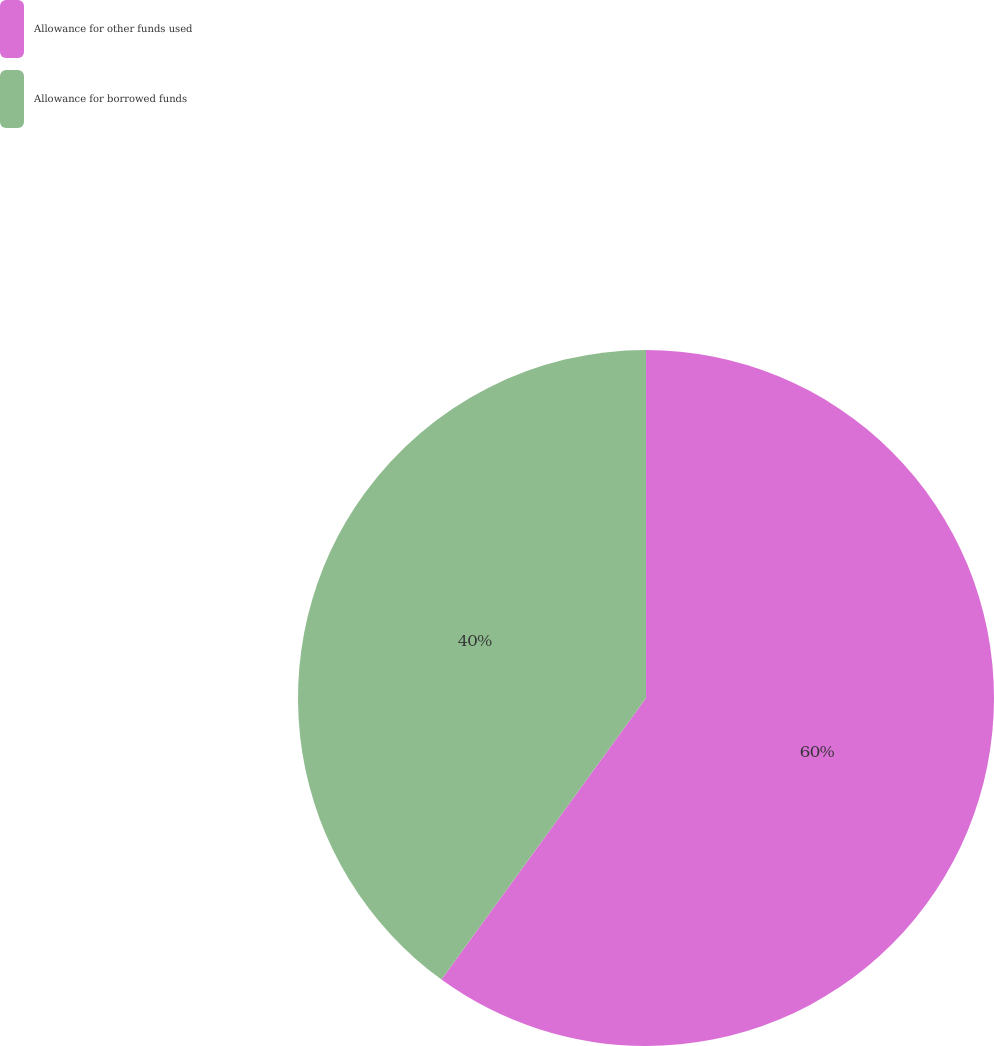<chart> <loc_0><loc_0><loc_500><loc_500><pie_chart><fcel>Allowance for other funds used<fcel>Allowance for borrowed funds<nl><fcel>60.0%<fcel>40.0%<nl></chart> 